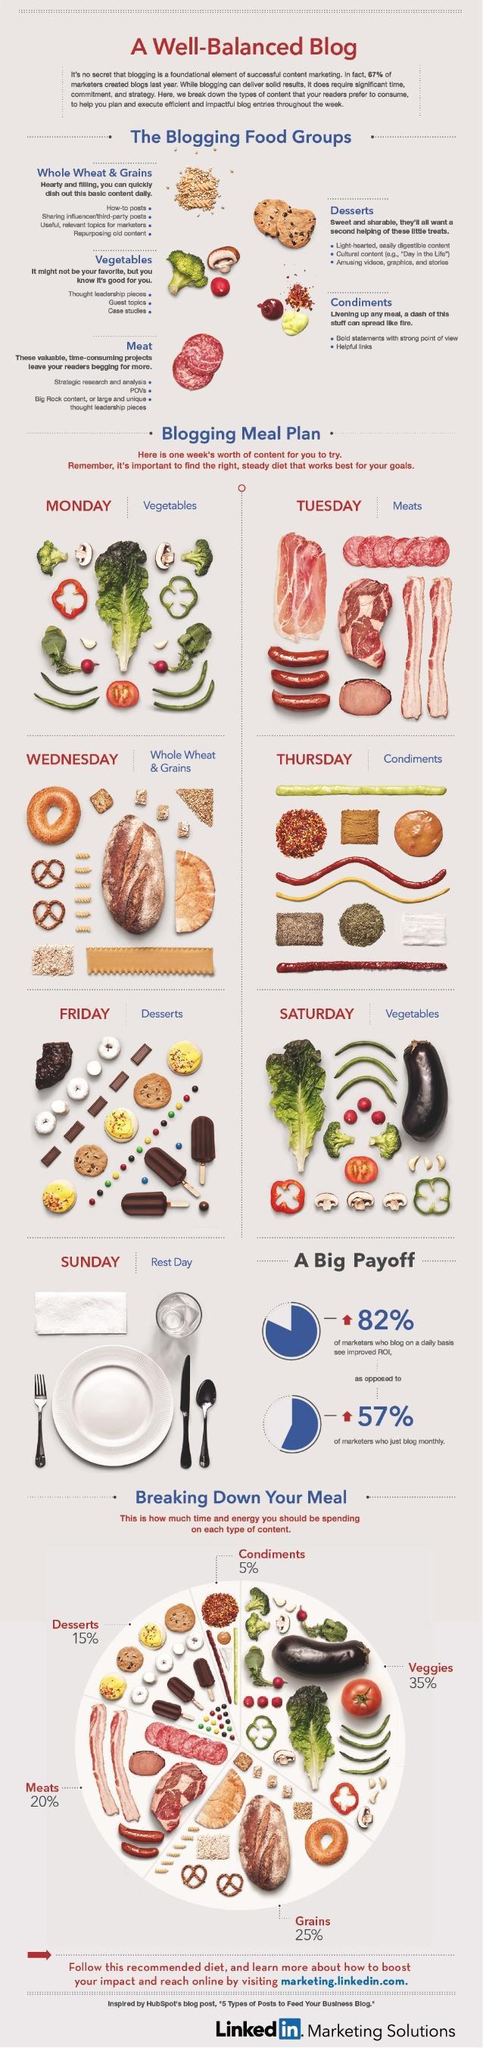How many food groups mentioned in this infographic?
Answer the question with a short phrase. 5 How many varieties of meats mentioned in this infographic? 6 Which has the highest share-grains, or veggies? veggies 